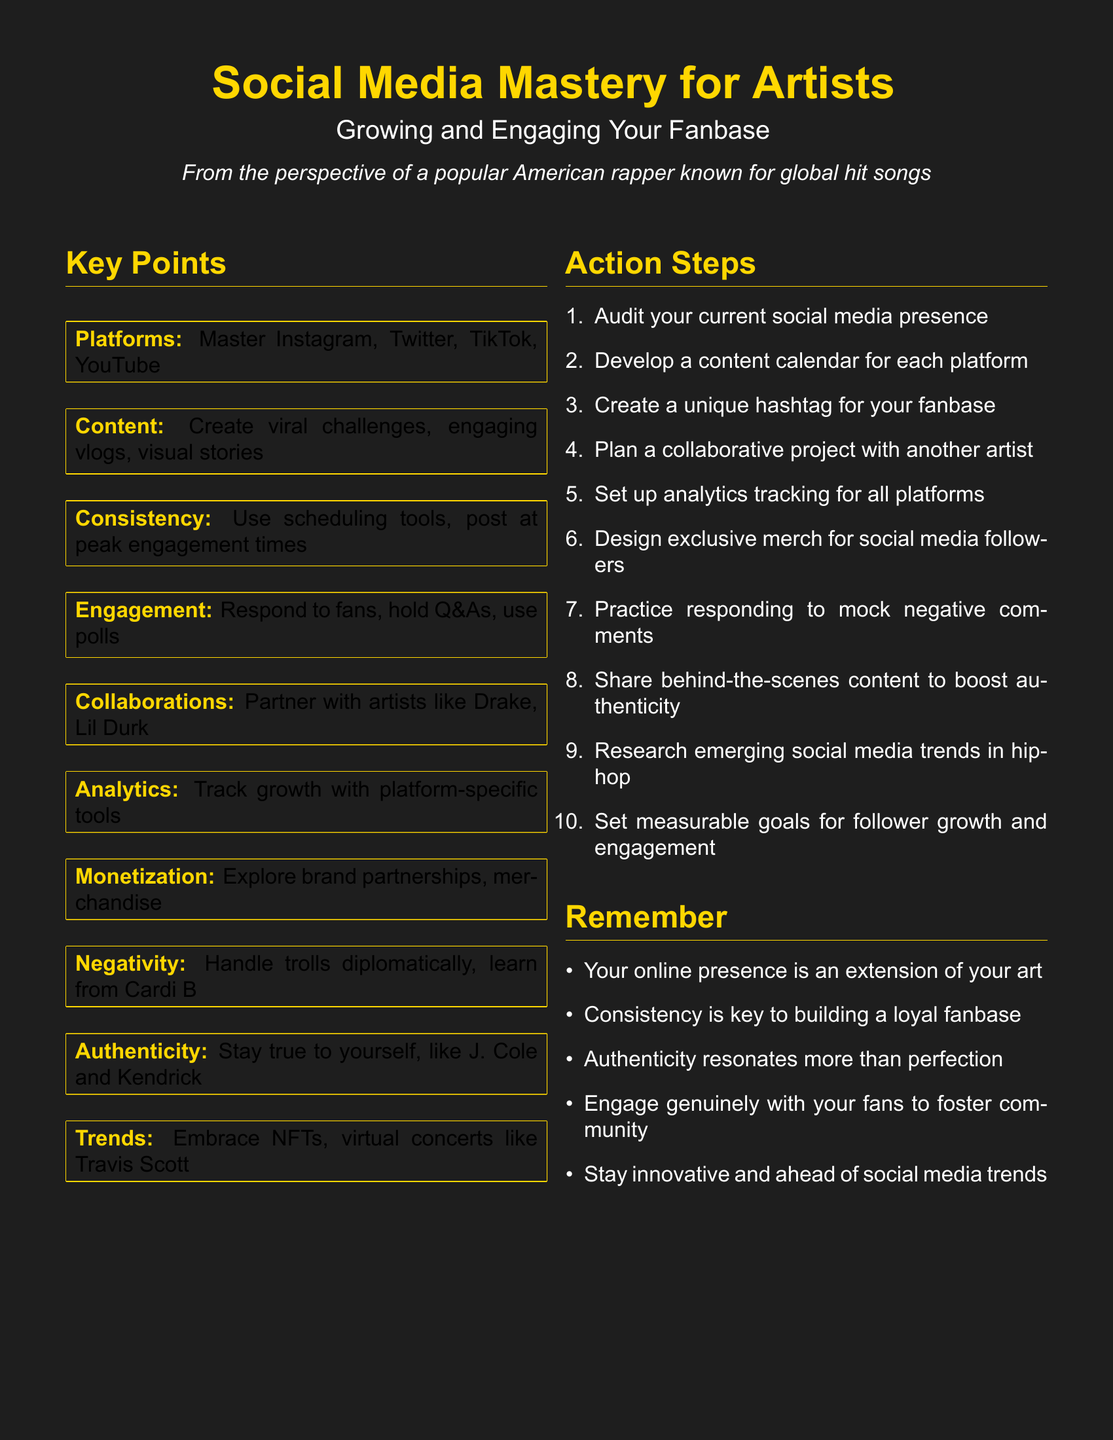What is the title of the lesson plan? The title of the lesson plan is stated prominently at the top of the document.
Answer: Social Media Mastery for Artists How many key points are listed in the lesson plan? The number of key points can be counted in the "Key Points" section of the document.
Answer: 10 Which platforms should artists master according to the lesson plan? The platforms are specifically mentioned in the "Key Points" section under the item labeled "Platforms."
Answer: Instagram, Twitter, TikTok, YouTube What is one action step recommended in the lesson plan? One of the action steps is outlined in the enumerated list of the "Action Steps" section.
Answer: Audit your current social media presence According to the lesson plan, what is a way to handle negativity? The document suggests referring to another artist for insights on handling negativity.
Answer: Learn from Cardi B What color is used for the text in the lesson plan? The color of the document text can be derived from the color specifications mentioned in the document.
Answer: White What should artists use to track growth? The lesson plan mentions tools specifically for analytics tracking, which can be found in the "Key Points" section.
Answer: Platform-specific tools What do artists need to create for their fanbase? This information can be found in the "Action Steps" section under the relevant item.
Answer: A unique hashtag What are artists advised to do with collaboration? The advice on collaborating is detailed in the "Key Points" section under "Collaborations."
Answer: Partner with artists like Drake, Lil Durk What is the overall theme of the lesson plan? The theme is inferred from the title and the context provided in the document.
Answer: Growing and Engaging Your Fanbase 